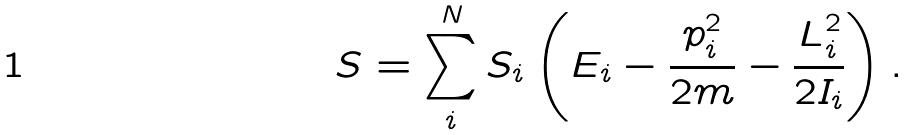Convert formula to latex. <formula><loc_0><loc_0><loc_500><loc_500>S = \sum _ { i } ^ { N } S _ { i } \left ( E _ { i } - \frac { p _ { i } ^ { 2 } } { 2 m } - \frac { L _ { i } ^ { 2 } } { 2 I _ { i } } \right ) .</formula> 